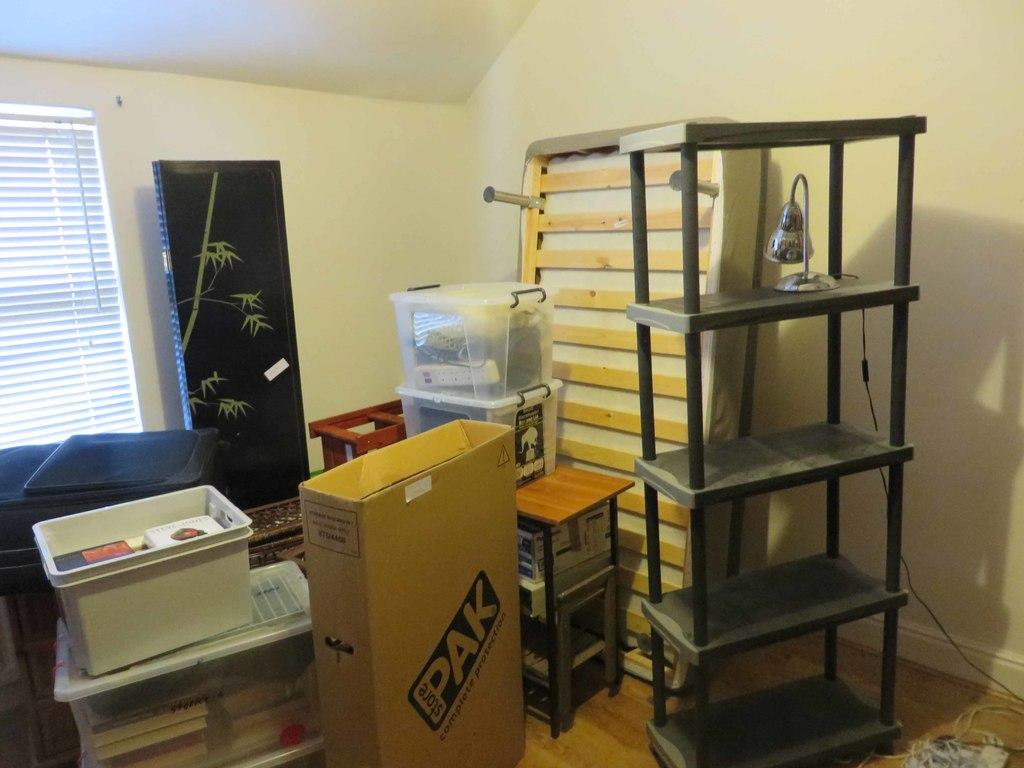<image>
Present a compact description of the photo's key features. Nearly empty shelving, boxes including one saying Pak, and some other items are stacked in the corner of a room. 